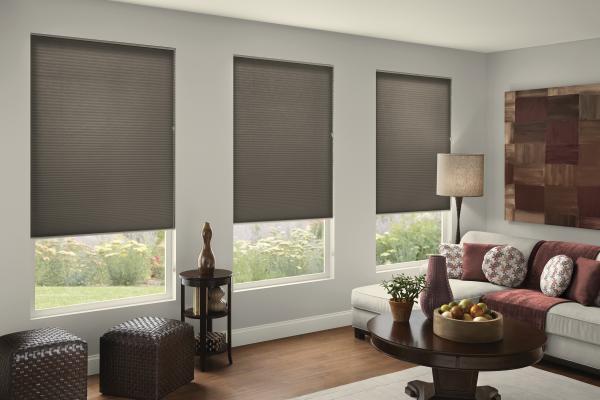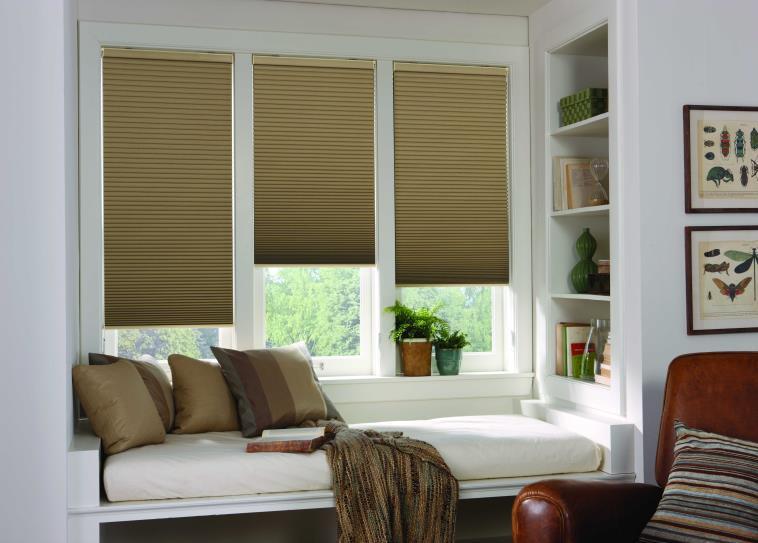The first image is the image on the left, the second image is the image on the right. Analyze the images presented: Is the assertion "The left and right image contains a total of seven blinds." valid? Answer yes or no. No. The first image is the image on the left, the second image is the image on the right. Examine the images to the left and right. Is the description "The left image shows three window screens on windows." accurate? Answer yes or no. Yes. 